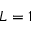Convert formula to latex. <formula><loc_0><loc_0><loc_500><loc_500>L = 1</formula> 